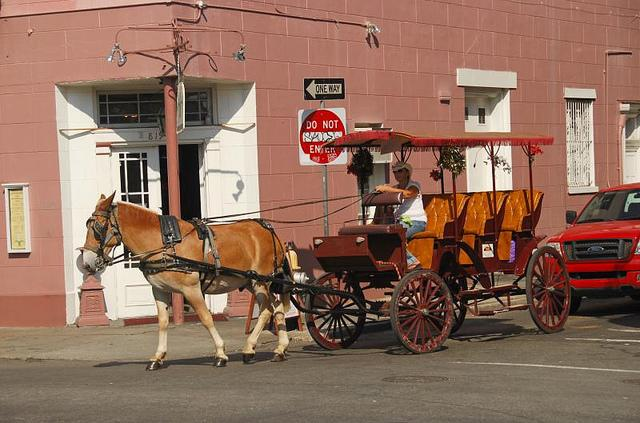What is the person in the carriage most likely looking for?

Choices:
A) food
B) hay
C) predators
D) passengers passengers 